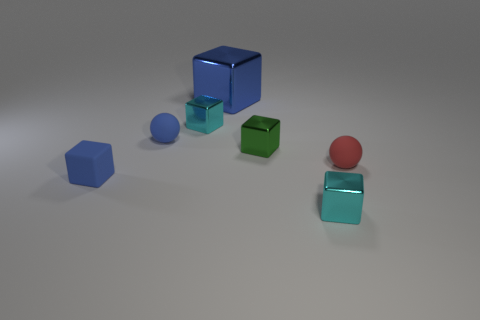Subtract all blue blocks. How many blocks are left? 3 Subtract 1 cubes. How many cubes are left? 4 Subtract all tiny rubber cubes. How many cubes are left? 4 Subtract all gray cubes. Subtract all purple cylinders. How many cubes are left? 5 Add 3 small red balls. How many objects exist? 10 Subtract all spheres. How many objects are left? 5 Add 2 large shiny cubes. How many large shiny cubes are left? 3 Add 3 large blue things. How many large blue things exist? 4 Subtract 0 cyan spheres. How many objects are left? 7 Subtract all small cyan shiny objects. Subtract all red objects. How many objects are left? 4 